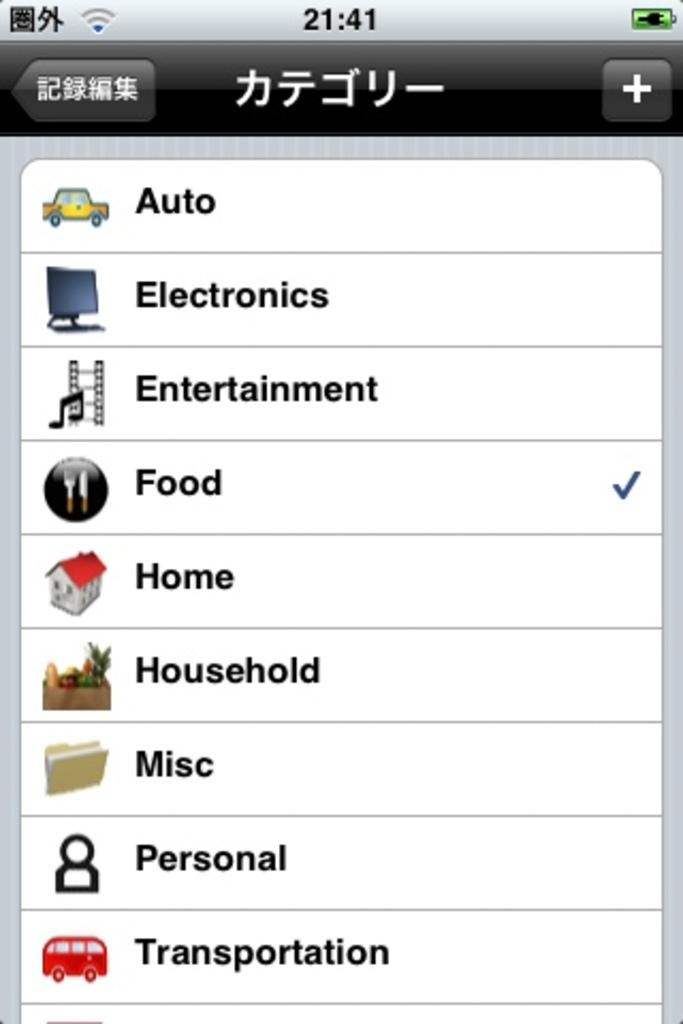<image>
Write a terse but informative summary of the picture. The screen has several options listed but only food is checked 